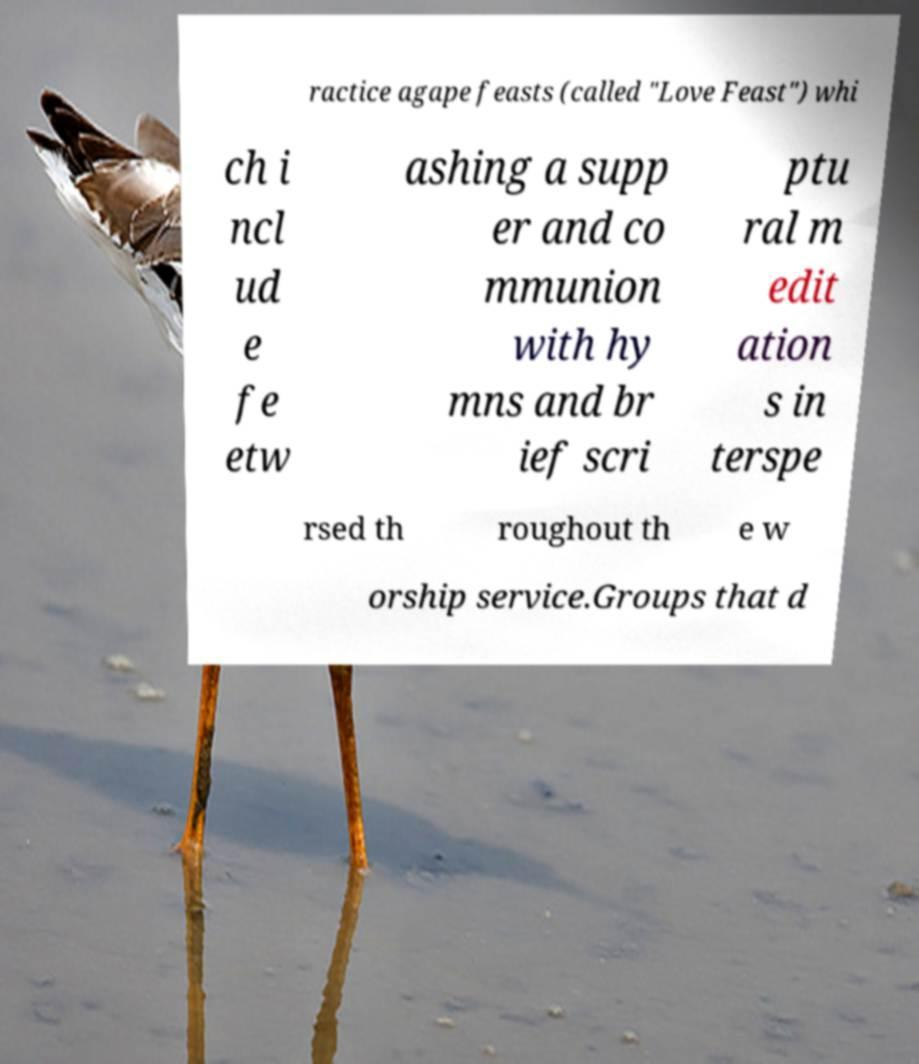For documentation purposes, I need the text within this image transcribed. Could you provide that? ractice agape feasts (called "Love Feast") whi ch i ncl ud e fe etw ashing a supp er and co mmunion with hy mns and br ief scri ptu ral m edit ation s in terspe rsed th roughout th e w orship service.Groups that d 